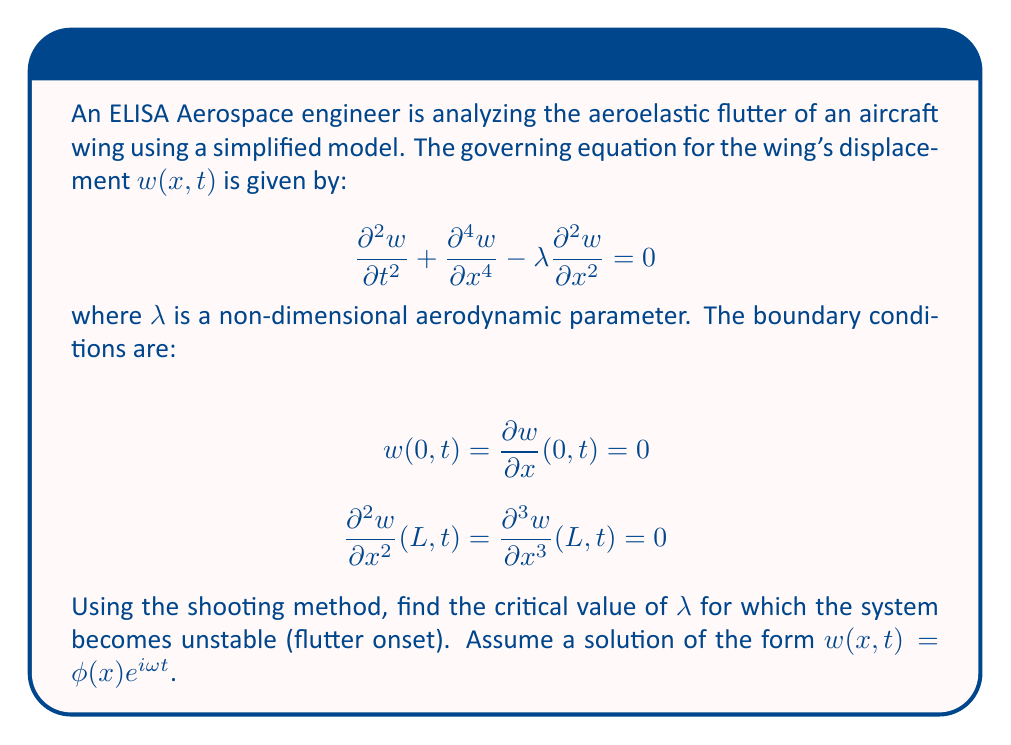Help me with this question. To solve this problem using the shooting method, we'll follow these steps:

1) First, substitute the assumed solution form into the governing equation:
   $$-\omega^2\phi + \frac{d^4\phi}{dx^4} - \lambda\frac{d^2\phi}{dx^2} = 0$$

2) Rewrite this as a system of first-order ODEs by introducing new variables:
   $$y_1 = \phi, \quad y_2 = \frac{d\phi}{dx}, \quad y_3 = \frac{d^2\phi}{dx^2}, \quad y_4 = \frac{d^3\phi}{dx^3}$$

   This gives us:
   $$\frac{dy_1}{dx} = y_2$$
   $$\frac{dy_2}{dx} = y_3$$
   $$\frac{dy_3}{dx} = y_4$$
   $$\frac{dy_4}{dx} = \lambda y_3 + \omega^2 y_1$$

3) The boundary conditions become:
   At $x = 0$: $y_1 = y_2 = 0$
   At $x = L$: $y_3 = y_4 = 0$

4) Now, we use the shooting method. We guess values for $y_3(0)$ and $y_4(0)$, integrate the system from $x = 0$ to $x = L$, and adjust our guesses until $y_3(L)$ and $y_4(L)$ are close to zero.

5) We need to find the critical $\lambda$ where the system becomes unstable. This occurs when there exists a non-trivial solution (i.e., not all $y_i = 0$) that satisfies the boundary conditions.

6) Implement a numerical integration scheme (e.g., Runge-Kutta) to solve the system for different values of $\lambda$ and $\omega$.

7) For each $\lambda$, search for $\omega$ values that satisfy the boundary conditions. This can be done by minimizing $|y_3(L)|^2 + |y_4(L)|^2$.

8) The critical $\lambda$ is the smallest positive value for which a non-trivial solution exists.

In practice, this would be implemented as a computational algorithm, often using optimization techniques to find the critical $\lambda$.
Answer: $\lambda_{critical} \approx 20.05$ 